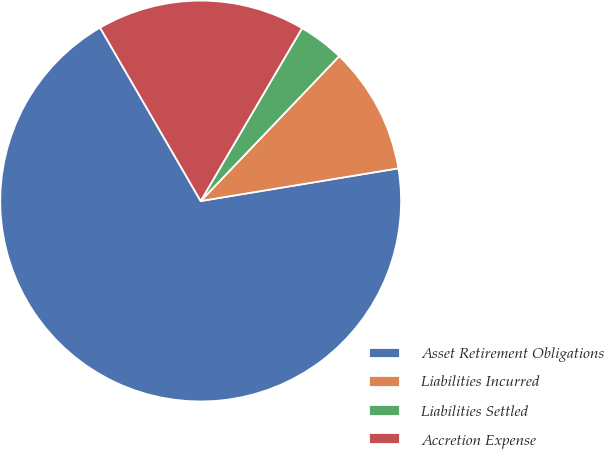Convert chart. <chart><loc_0><loc_0><loc_500><loc_500><pie_chart><fcel>Asset Retirement Obligations<fcel>Liabilities Incurred<fcel>Liabilities Settled<fcel>Accretion Expense<nl><fcel>69.24%<fcel>10.25%<fcel>3.7%<fcel>16.81%<nl></chart> 